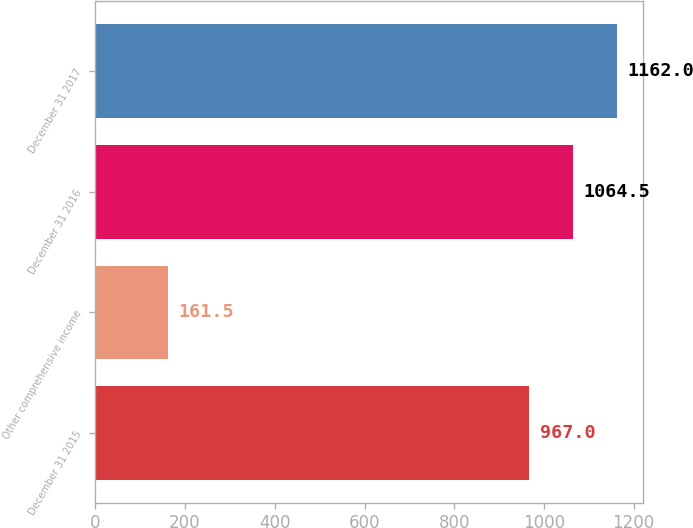Convert chart. <chart><loc_0><loc_0><loc_500><loc_500><bar_chart><fcel>December 31 2015<fcel>Other comprehensive income<fcel>December 31 2016<fcel>December 31 2017<nl><fcel>967<fcel>161.5<fcel>1064.5<fcel>1162<nl></chart> 